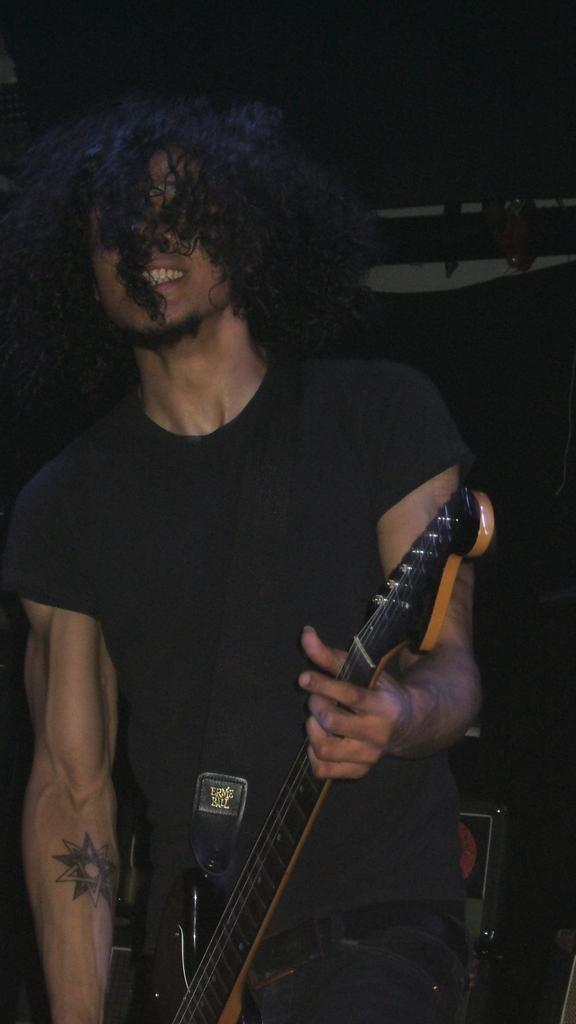Who is the main subject in the image? There is a man in the image. What is the man wearing? The man is wearing a black t-shirt. What is the man holding in the image? The man is holding a guitar. What can be observed about the background of the image? The background of the image is dark. How does the man's cough affect the guitar in the image? There is no mention of the man coughing in the image, so it cannot be determined how it would affect the guitar. 